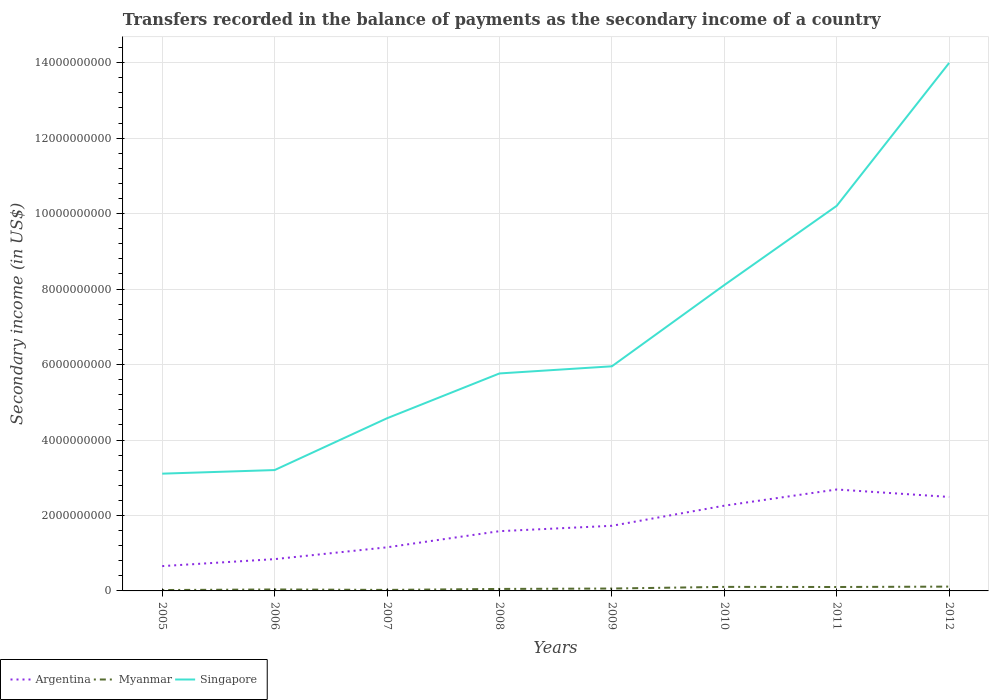Does the line corresponding to Argentina intersect with the line corresponding to Singapore?
Provide a short and direct response. No. Across all years, what is the maximum secondary income of in Singapore?
Provide a short and direct response. 3.11e+09. What is the total secondary income of in Myanmar in the graph?
Give a very brief answer. -2.54e+07. What is the difference between the highest and the second highest secondary income of in Argentina?
Provide a succinct answer. 2.03e+09. Is the secondary income of in Singapore strictly greater than the secondary income of in Argentina over the years?
Keep it short and to the point. No. How many years are there in the graph?
Offer a terse response. 8. What is the difference between two consecutive major ticks on the Y-axis?
Ensure brevity in your answer.  2.00e+09. Does the graph contain grids?
Keep it short and to the point. Yes. Where does the legend appear in the graph?
Ensure brevity in your answer.  Bottom left. How many legend labels are there?
Offer a very short reply. 3. What is the title of the graph?
Offer a very short reply. Transfers recorded in the balance of payments as the secondary income of a country. Does "Canada" appear as one of the legend labels in the graph?
Your answer should be compact. No. What is the label or title of the Y-axis?
Ensure brevity in your answer.  Secondary income (in US$). What is the Secondary income (in US$) in Argentina in 2005?
Ensure brevity in your answer.  6.58e+08. What is the Secondary income (in US$) of Myanmar in 2005?
Offer a very short reply. 2.36e+07. What is the Secondary income (in US$) of Singapore in 2005?
Your answer should be very brief. 3.11e+09. What is the Secondary income (in US$) in Argentina in 2006?
Provide a short and direct response. 8.43e+08. What is the Secondary income (in US$) in Myanmar in 2006?
Keep it short and to the point. 3.87e+07. What is the Secondary income (in US$) in Singapore in 2006?
Your response must be concise. 3.20e+09. What is the Secondary income (in US$) in Argentina in 2007?
Provide a succinct answer. 1.16e+09. What is the Secondary income (in US$) of Myanmar in 2007?
Keep it short and to the point. 2.72e+07. What is the Secondary income (in US$) in Singapore in 2007?
Offer a terse response. 4.58e+09. What is the Secondary income (in US$) in Argentina in 2008?
Provide a short and direct response. 1.58e+09. What is the Secondary income (in US$) of Myanmar in 2008?
Give a very brief answer. 5.26e+07. What is the Secondary income (in US$) of Singapore in 2008?
Your response must be concise. 5.76e+09. What is the Secondary income (in US$) in Argentina in 2009?
Offer a very short reply. 1.73e+09. What is the Secondary income (in US$) of Myanmar in 2009?
Provide a succinct answer. 6.34e+07. What is the Secondary income (in US$) in Singapore in 2009?
Keep it short and to the point. 5.95e+09. What is the Secondary income (in US$) of Argentina in 2010?
Your response must be concise. 2.26e+09. What is the Secondary income (in US$) in Myanmar in 2010?
Provide a short and direct response. 1.07e+08. What is the Secondary income (in US$) of Singapore in 2010?
Offer a very short reply. 8.11e+09. What is the Secondary income (in US$) in Argentina in 2011?
Keep it short and to the point. 2.69e+09. What is the Secondary income (in US$) of Myanmar in 2011?
Keep it short and to the point. 1.04e+08. What is the Secondary income (in US$) in Singapore in 2011?
Your response must be concise. 1.02e+1. What is the Secondary income (in US$) of Argentina in 2012?
Keep it short and to the point. 2.49e+09. What is the Secondary income (in US$) of Myanmar in 2012?
Offer a very short reply. 1.14e+08. What is the Secondary income (in US$) in Singapore in 2012?
Offer a terse response. 1.40e+1. Across all years, what is the maximum Secondary income (in US$) in Argentina?
Your response must be concise. 2.69e+09. Across all years, what is the maximum Secondary income (in US$) in Myanmar?
Provide a succinct answer. 1.14e+08. Across all years, what is the maximum Secondary income (in US$) in Singapore?
Make the answer very short. 1.40e+1. Across all years, what is the minimum Secondary income (in US$) in Argentina?
Your answer should be compact. 6.58e+08. Across all years, what is the minimum Secondary income (in US$) in Myanmar?
Your response must be concise. 2.36e+07. Across all years, what is the minimum Secondary income (in US$) of Singapore?
Your answer should be very brief. 3.11e+09. What is the total Secondary income (in US$) of Argentina in the graph?
Your answer should be very brief. 1.34e+1. What is the total Secondary income (in US$) in Myanmar in the graph?
Your answer should be very brief. 5.31e+08. What is the total Secondary income (in US$) of Singapore in the graph?
Keep it short and to the point. 5.49e+1. What is the difference between the Secondary income (in US$) of Argentina in 2005 and that in 2006?
Ensure brevity in your answer.  -1.85e+08. What is the difference between the Secondary income (in US$) in Myanmar in 2005 and that in 2006?
Your answer should be very brief. -1.51e+07. What is the difference between the Secondary income (in US$) in Singapore in 2005 and that in 2006?
Keep it short and to the point. -9.54e+07. What is the difference between the Secondary income (in US$) of Argentina in 2005 and that in 2007?
Offer a terse response. -4.98e+08. What is the difference between the Secondary income (in US$) in Myanmar in 2005 and that in 2007?
Offer a terse response. -3.60e+06. What is the difference between the Secondary income (in US$) in Singapore in 2005 and that in 2007?
Offer a very short reply. -1.47e+09. What is the difference between the Secondary income (in US$) in Argentina in 2005 and that in 2008?
Your response must be concise. -9.26e+08. What is the difference between the Secondary income (in US$) in Myanmar in 2005 and that in 2008?
Provide a short and direct response. -2.90e+07. What is the difference between the Secondary income (in US$) of Singapore in 2005 and that in 2008?
Give a very brief answer. -2.66e+09. What is the difference between the Secondary income (in US$) in Argentina in 2005 and that in 2009?
Ensure brevity in your answer.  -1.07e+09. What is the difference between the Secondary income (in US$) of Myanmar in 2005 and that in 2009?
Your response must be concise. -3.98e+07. What is the difference between the Secondary income (in US$) of Singapore in 2005 and that in 2009?
Offer a very short reply. -2.85e+09. What is the difference between the Secondary income (in US$) in Argentina in 2005 and that in 2010?
Your answer should be compact. -1.60e+09. What is the difference between the Secondary income (in US$) in Myanmar in 2005 and that in 2010?
Give a very brief answer. -8.35e+07. What is the difference between the Secondary income (in US$) of Singapore in 2005 and that in 2010?
Your answer should be compact. -5.00e+09. What is the difference between the Secondary income (in US$) of Argentina in 2005 and that in 2011?
Offer a very short reply. -2.03e+09. What is the difference between the Secondary income (in US$) of Myanmar in 2005 and that in 2011?
Provide a succinct answer. -8.04e+07. What is the difference between the Secondary income (in US$) in Singapore in 2005 and that in 2011?
Provide a short and direct response. -7.10e+09. What is the difference between the Secondary income (in US$) of Argentina in 2005 and that in 2012?
Your response must be concise. -1.83e+09. What is the difference between the Secondary income (in US$) in Myanmar in 2005 and that in 2012?
Your answer should be compact. -9.07e+07. What is the difference between the Secondary income (in US$) of Singapore in 2005 and that in 2012?
Your response must be concise. -1.09e+1. What is the difference between the Secondary income (in US$) of Argentina in 2006 and that in 2007?
Provide a succinct answer. -3.13e+08. What is the difference between the Secondary income (in US$) in Myanmar in 2006 and that in 2007?
Your answer should be very brief. 1.15e+07. What is the difference between the Secondary income (in US$) in Singapore in 2006 and that in 2007?
Provide a succinct answer. -1.37e+09. What is the difference between the Secondary income (in US$) in Argentina in 2006 and that in 2008?
Provide a short and direct response. -7.41e+08. What is the difference between the Secondary income (in US$) of Myanmar in 2006 and that in 2008?
Give a very brief answer. -1.40e+07. What is the difference between the Secondary income (in US$) in Singapore in 2006 and that in 2008?
Make the answer very short. -2.56e+09. What is the difference between the Secondary income (in US$) of Argentina in 2006 and that in 2009?
Your answer should be very brief. -8.84e+08. What is the difference between the Secondary income (in US$) of Myanmar in 2006 and that in 2009?
Make the answer very short. -2.48e+07. What is the difference between the Secondary income (in US$) in Singapore in 2006 and that in 2009?
Offer a terse response. -2.75e+09. What is the difference between the Secondary income (in US$) of Argentina in 2006 and that in 2010?
Your answer should be compact. -1.42e+09. What is the difference between the Secondary income (in US$) in Myanmar in 2006 and that in 2010?
Offer a terse response. -6.84e+07. What is the difference between the Secondary income (in US$) in Singapore in 2006 and that in 2010?
Your response must be concise. -4.90e+09. What is the difference between the Secondary income (in US$) in Argentina in 2006 and that in 2011?
Provide a short and direct response. -1.85e+09. What is the difference between the Secondary income (in US$) of Myanmar in 2006 and that in 2011?
Give a very brief answer. -6.53e+07. What is the difference between the Secondary income (in US$) in Singapore in 2006 and that in 2011?
Provide a short and direct response. -7.00e+09. What is the difference between the Secondary income (in US$) of Argentina in 2006 and that in 2012?
Offer a very short reply. -1.65e+09. What is the difference between the Secondary income (in US$) in Myanmar in 2006 and that in 2012?
Your answer should be very brief. -7.56e+07. What is the difference between the Secondary income (in US$) in Singapore in 2006 and that in 2012?
Offer a very short reply. -1.08e+1. What is the difference between the Secondary income (in US$) in Argentina in 2007 and that in 2008?
Your answer should be compact. -4.28e+08. What is the difference between the Secondary income (in US$) in Myanmar in 2007 and that in 2008?
Your answer should be very brief. -2.54e+07. What is the difference between the Secondary income (in US$) of Singapore in 2007 and that in 2008?
Your answer should be very brief. -1.19e+09. What is the difference between the Secondary income (in US$) of Argentina in 2007 and that in 2009?
Ensure brevity in your answer.  -5.70e+08. What is the difference between the Secondary income (in US$) in Myanmar in 2007 and that in 2009?
Give a very brief answer. -3.62e+07. What is the difference between the Secondary income (in US$) in Singapore in 2007 and that in 2009?
Your answer should be very brief. -1.38e+09. What is the difference between the Secondary income (in US$) in Argentina in 2007 and that in 2010?
Provide a succinct answer. -1.10e+09. What is the difference between the Secondary income (in US$) in Myanmar in 2007 and that in 2010?
Offer a very short reply. -7.99e+07. What is the difference between the Secondary income (in US$) in Singapore in 2007 and that in 2010?
Keep it short and to the point. -3.53e+09. What is the difference between the Secondary income (in US$) of Argentina in 2007 and that in 2011?
Ensure brevity in your answer.  -1.53e+09. What is the difference between the Secondary income (in US$) in Myanmar in 2007 and that in 2011?
Give a very brief answer. -7.68e+07. What is the difference between the Secondary income (in US$) of Singapore in 2007 and that in 2011?
Give a very brief answer. -5.63e+09. What is the difference between the Secondary income (in US$) in Argentina in 2007 and that in 2012?
Provide a succinct answer. -1.34e+09. What is the difference between the Secondary income (in US$) in Myanmar in 2007 and that in 2012?
Offer a terse response. -8.71e+07. What is the difference between the Secondary income (in US$) of Singapore in 2007 and that in 2012?
Your answer should be very brief. -9.42e+09. What is the difference between the Secondary income (in US$) of Argentina in 2008 and that in 2009?
Offer a terse response. -1.43e+08. What is the difference between the Secondary income (in US$) in Myanmar in 2008 and that in 2009?
Your answer should be compact. -1.08e+07. What is the difference between the Secondary income (in US$) in Singapore in 2008 and that in 2009?
Your response must be concise. -1.89e+08. What is the difference between the Secondary income (in US$) of Argentina in 2008 and that in 2010?
Provide a short and direct response. -6.76e+08. What is the difference between the Secondary income (in US$) of Myanmar in 2008 and that in 2010?
Your response must be concise. -5.45e+07. What is the difference between the Secondary income (in US$) in Singapore in 2008 and that in 2010?
Your answer should be compact. -2.34e+09. What is the difference between the Secondary income (in US$) in Argentina in 2008 and that in 2011?
Your response must be concise. -1.10e+09. What is the difference between the Secondary income (in US$) in Myanmar in 2008 and that in 2011?
Make the answer very short. -5.13e+07. What is the difference between the Secondary income (in US$) in Singapore in 2008 and that in 2011?
Your answer should be very brief. -4.44e+09. What is the difference between the Secondary income (in US$) of Argentina in 2008 and that in 2012?
Make the answer very short. -9.07e+08. What is the difference between the Secondary income (in US$) of Myanmar in 2008 and that in 2012?
Your answer should be compact. -6.17e+07. What is the difference between the Secondary income (in US$) in Singapore in 2008 and that in 2012?
Your answer should be compact. -8.23e+09. What is the difference between the Secondary income (in US$) in Argentina in 2009 and that in 2010?
Your answer should be very brief. -5.33e+08. What is the difference between the Secondary income (in US$) of Myanmar in 2009 and that in 2010?
Your answer should be compact. -4.37e+07. What is the difference between the Secondary income (in US$) in Singapore in 2009 and that in 2010?
Provide a succinct answer. -2.15e+09. What is the difference between the Secondary income (in US$) in Argentina in 2009 and that in 2011?
Your answer should be compact. -9.62e+08. What is the difference between the Secondary income (in US$) of Myanmar in 2009 and that in 2011?
Give a very brief answer. -4.05e+07. What is the difference between the Secondary income (in US$) of Singapore in 2009 and that in 2011?
Your answer should be compact. -4.25e+09. What is the difference between the Secondary income (in US$) in Argentina in 2009 and that in 2012?
Give a very brief answer. -7.65e+08. What is the difference between the Secondary income (in US$) in Myanmar in 2009 and that in 2012?
Your answer should be very brief. -5.09e+07. What is the difference between the Secondary income (in US$) in Singapore in 2009 and that in 2012?
Your response must be concise. -8.04e+09. What is the difference between the Secondary income (in US$) of Argentina in 2010 and that in 2011?
Your answer should be very brief. -4.29e+08. What is the difference between the Secondary income (in US$) of Myanmar in 2010 and that in 2011?
Give a very brief answer. 3.15e+06. What is the difference between the Secondary income (in US$) of Singapore in 2010 and that in 2011?
Provide a short and direct response. -2.10e+09. What is the difference between the Secondary income (in US$) in Argentina in 2010 and that in 2012?
Your response must be concise. -2.31e+08. What is the difference between the Secondary income (in US$) in Myanmar in 2010 and that in 2012?
Your answer should be very brief. -7.21e+06. What is the difference between the Secondary income (in US$) in Singapore in 2010 and that in 2012?
Offer a terse response. -5.89e+09. What is the difference between the Secondary income (in US$) of Argentina in 2011 and that in 2012?
Keep it short and to the point. 1.97e+08. What is the difference between the Secondary income (in US$) of Myanmar in 2011 and that in 2012?
Offer a very short reply. -1.04e+07. What is the difference between the Secondary income (in US$) of Singapore in 2011 and that in 2012?
Give a very brief answer. -3.79e+09. What is the difference between the Secondary income (in US$) of Argentina in 2005 and the Secondary income (in US$) of Myanmar in 2006?
Ensure brevity in your answer.  6.19e+08. What is the difference between the Secondary income (in US$) in Argentina in 2005 and the Secondary income (in US$) in Singapore in 2006?
Give a very brief answer. -2.55e+09. What is the difference between the Secondary income (in US$) in Myanmar in 2005 and the Secondary income (in US$) in Singapore in 2006?
Give a very brief answer. -3.18e+09. What is the difference between the Secondary income (in US$) of Argentina in 2005 and the Secondary income (in US$) of Myanmar in 2007?
Your response must be concise. 6.31e+08. What is the difference between the Secondary income (in US$) in Argentina in 2005 and the Secondary income (in US$) in Singapore in 2007?
Offer a terse response. -3.92e+09. What is the difference between the Secondary income (in US$) in Myanmar in 2005 and the Secondary income (in US$) in Singapore in 2007?
Keep it short and to the point. -4.55e+09. What is the difference between the Secondary income (in US$) of Argentina in 2005 and the Secondary income (in US$) of Myanmar in 2008?
Keep it short and to the point. 6.05e+08. What is the difference between the Secondary income (in US$) of Argentina in 2005 and the Secondary income (in US$) of Singapore in 2008?
Your response must be concise. -5.11e+09. What is the difference between the Secondary income (in US$) in Myanmar in 2005 and the Secondary income (in US$) in Singapore in 2008?
Make the answer very short. -5.74e+09. What is the difference between the Secondary income (in US$) of Argentina in 2005 and the Secondary income (in US$) of Myanmar in 2009?
Ensure brevity in your answer.  5.94e+08. What is the difference between the Secondary income (in US$) of Argentina in 2005 and the Secondary income (in US$) of Singapore in 2009?
Ensure brevity in your answer.  -5.30e+09. What is the difference between the Secondary income (in US$) of Myanmar in 2005 and the Secondary income (in US$) of Singapore in 2009?
Your response must be concise. -5.93e+09. What is the difference between the Secondary income (in US$) of Argentina in 2005 and the Secondary income (in US$) of Myanmar in 2010?
Keep it short and to the point. 5.51e+08. What is the difference between the Secondary income (in US$) of Argentina in 2005 and the Secondary income (in US$) of Singapore in 2010?
Provide a short and direct response. -7.45e+09. What is the difference between the Secondary income (in US$) in Myanmar in 2005 and the Secondary income (in US$) in Singapore in 2010?
Provide a short and direct response. -8.08e+09. What is the difference between the Secondary income (in US$) in Argentina in 2005 and the Secondary income (in US$) in Myanmar in 2011?
Provide a succinct answer. 5.54e+08. What is the difference between the Secondary income (in US$) in Argentina in 2005 and the Secondary income (in US$) in Singapore in 2011?
Give a very brief answer. -9.55e+09. What is the difference between the Secondary income (in US$) of Myanmar in 2005 and the Secondary income (in US$) of Singapore in 2011?
Offer a very short reply. -1.02e+1. What is the difference between the Secondary income (in US$) in Argentina in 2005 and the Secondary income (in US$) in Myanmar in 2012?
Offer a terse response. 5.44e+08. What is the difference between the Secondary income (in US$) of Argentina in 2005 and the Secondary income (in US$) of Singapore in 2012?
Your answer should be compact. -1.33e+1. What is the difference between the Secondary income (in US$) of Myanmar in 2005 and the Secondary income (in US$) of Singapore in 2012?
Give a very brief answer. -1.40e+1. What is the difference between the Secondary income (in US$) of Argentina in 2006 and the Secondary income (in US$) of Myanmar in 2007?
Your answer should be compact. 8.15e+08. What is the difference between the Secondary income (in US$) in Argentina in 2006 and the Secondary income (in US$) in Singapore in 2007?
Give a very brief answer. -3.73e+09. What is the difference between the Secondary income (in US$) of Myanmar in 2006 and the Secondary income (in US$) of Singapore in 2007?
Your answer should be compact. -4.54e+09. What is the difference between the Secondary income (in US$) in Argentina in 2006 and the Secondary income (in US$) in Myanmar in 2008?
Your response must be concise. 7.90e+08. What is the difference between the Secondary income (in US$) in Argentina in 2006 and the Secondary income (in US$) in Singapore in 2008?
Give a very brief answer. -4.92e+09. What is the difference between the Secondary income (in US$) in Myanmar in 2006 and the Secondary income (in US$) in Singapore in 2008?
Ensure brevity in your answer.  -5.73e+09. What is the difference between the Secondary income (in US$) of Argentina in 2006 and the Secondary income (in US$) of Myanmar in 2009?
Provide a succinct answer. 7.79e+08. What is the difference between the Secondary income (in US$) of Argentina in 2006 and the Secondary income (in US$) of Singapore in 2009?
Ensure brevity in your answer.  -5.11e+09. What is the difference between the Secondary income (in US$) of Myanmar in 2006 and the Secondary income (in US$) of Singapore in 2009?
Your answer should be very brief. -5.91e+09. What is the difference between the Secondary income (in US$) of Argentina in 2006 and the Secondary income (in US$) of Myanmar in 2010?
Give a very brief answer. 7.36e+08. What is the difference between the Secondary income (in US$) of Argentina in 2006 and the Secondary income (in US$) of Singapore in 2010?
Keep it short and to the point. -7.26e+09. What is the difference between the Secondary income (in US$) in Myanmar in 2006 and the Secondary income (in US$) in Singapore in 2010?
Your answer should be compact. -8.07e+09. What is the difference between the Secondary income (in US$) of Argentina in 2006 and the Secondary income (in US$) of Myanmar in 2011?
Give a very brief answer. 7.39e+08. What is the difference between the Secondary income (in US$) of Argentina in 2006 and the Secondary income (in US$) of Singapore in 2011?
Ensure brevity in your answer.  -9.36e+09. What is the difference between the Secondary income (in US$) of Myanmar in 2006 and the Secondary income (in US$) of Singapore in 2011?
Provide a short and direct response. -1.02e+1. What is the difference between the Secondary income (in US$) of Argentina in 2006 and the Secondary income (in US$) of Myanmar in 2012?
Offer a very short reply. 7.28e+08. What is the difference between the Secondary income (in US$) in Argentina in 2006 and the Secondary income (in US$) in Singapore in 2012?
Keep it short and to the point. -1.32e+1. What is the difference between the Secondary income (in US$) of Myanmar in 2006 and the Secondary income (in US$) of Singapore in 2012?
Keep it short and to the point. -1.40e+1. What is the difference between the Secondary income (in US$) of Argentina in 2007 and the Secondary income (in US$) of Myanmar in 2008?
Your answer should be compact. 1.10e+09. What is the difference between the Secondary income (in US$) of Argentina in 2007 and the Secondary income (in US$) of Singapore in 2008?
Offer a terse response. -4.61e+09. What is the difference between the Secondary income (in US$) in Myanmar in 2007 and the Secondary income (in US$) in Singapore in 2008?
Ensure brevity in your answer.  -5.74e+09. What is the difference between the Secondary income (in US$) in Argentina in 2007 and the Secondary income (in US$) in Myanmar in 2009?
Your response must be concise. 1.09e+09. What is the difference between the Secondary income (in US$) of Argentina in 2007 and the Secondary income (in US$) of Singapore in 2009?
Ensure brevity in your answer.  -4.80e+09. What is the difference between the Secondary income (in US$) in Myanmar in 2007 and the Secondary income (in US$) in Singapore in 2009?
Your answer should be compact. -5.93e+09. What is the difference between the Secondary income (in US$) of Argentina in 2007 and the Secondary income (in US$) of Myanmar in 2010?
Provide a short and direct response. 1.05e+09. What is the difference between the Secondary income (in US$) of Argentina in 2007 and the Secondary income (in US$) of Singapore in 2010?
Ensure brevity in your answer.  -6.95e+09. What is the difference between the Secondary income (in US$) in Myanmar in 2007 and the Secondary income (in US$) in Singapore in 2010?
Make the answer very short. -8.08e+09. What is the difference between the Secondary income (in US$) in Argentina in 2007 and the Secondary income (in US$) in Myanmar in 2011?
Your answer should be compact. 1.05e+09. What is the difference between the Secondary income (in US$) in Argentina in 2007 and the Secondary income (in US$) in Singapore in 2011?
Provide a succinct answer. -9.05e+09. What is the difference between the Secondary income (in US$) in Myanmar in 2007 and the Secondary income (in US$) in Singapore in 2011?
Your answer should be compact. -1.02e+1. What is the difference between the Secondary income (in US$) of Argentina in 2007 and the Secondary income (in US$) of Myanmar in 2012?
Ensure brevity in your answer.  1.04e+09. What is the difference between the Secondary income (in US$) in Argentina in 2007 and the Secondary income (in US$) in Singapore in 2012?
Make the answer very short. -1.28e+1. What is the difference between the Secondary income (in US$) in Myanmar in 2007 and the Secondary income (in US$) in Singapore in 2012?
Keep it short and to the point. -1.40e+1. What is the difference between the Secondary income (in US$) of Argentina in 2008 and the Secondary income (in US$) of Myanmar in 2009?
Your answer should be very brief. 1.52e+09. What is the difference between the Secondary income (in US$) in Argentina in 2008 and the Secondary income (in US$) in Singapore in 2009?
Your answer should be compact. -4.37e+09. What is the difference between the Secondary income (in US$) of Myanmar in 2008 and the Secondary income (in US$) of Singapore in 2009?
Your answer should be compact. -5.90e+09. What is the difference between the Secondary income (in US$) of Argentina in 2008 and the Secondary income (in US$) of Myanmar in 2010?
Your answer should be very brief. 1.48e+09. What is the difference between the Secondary income (in US$) in Argentina in 2008 and the Secondary income (in US$) in Singapore in 2010?
Provide a succinct answer. -6.52e+09. What is the difference between the Secondary income (in US$) of Myanmar in 2008 and the Secondary income (in US$) of Singapore in 2010?
Give a very brief answer. -8.05e+09. What is the difference between the Secondary income (in US$) in Argentina in 2008 and the Secondary income (in US$) in Myanmar in 2011?
Keep it short and to the point. 1.48e+09. What is the difference between the Secondary income (in US$) in Argentina in 2008 and the Secondary income (in US$) in Singapore in 2011?
Your answer should be very brief. -8.62e+09. What is the difference between the Secondary income (in US$) in Myanmar in 2008 and the Secondary income (in US$) in Singapore in 2011?
Provide a succinct answer. -1.02e+1. What is the difference between the Secondary income (in US$) in Argentina in 2008 and the Secondary income (in US$) in Myanmar in 2012?
Make the answer very short. 1.47e+09. What is the difference between the Secondary income (in US$) in Argentina in 2008 and the Secondary income (in US$) in Singapore in 2012?
Your response must be concise. -1.24e+1. What is the difference between the Secondary income (in US$) of Myanmar in 2008 and the Secondary income (in US$) of Singapore in 2012?
Make the answer very short. -1.39e+1. What is the difference between the Secondary income (in US$) of Argentina in 2009 and the Secondary income (in US$) of Myanmar in 2010?
Give a very brief answer. 1.62e+09. What is the difference between the Secondary income (in US$) in Argentina in 2009 and the Secondary income (in US$) in Singapore in 2010?
Offer a terse response. -6.38e+09. What is the difference between the Secondary income (in US$) in Myanmar in 2009 and the Secondary income (in US$) in Singapore in 2010?
Provide a short and direct response. -8.04e+09. What is the difference between the Secondary income (in US$) of Argentina in 2009 and the Secondary income (in US$) of Myanmar in 2011?
Your answer should be very brief. 1.62e+09. What is the difference between the Secondary income (in US$) of Argentina in 2009 and the Secondary income (in US$) of Singapore in 2011?
Offer a terse response. -8.48e+09. What is the difference between the Secondary income (in US$) in Myanmar in 2009 and the Secondary income (in US$) in Singapore in 2011?
Make the answer very short. -1.01e+1. What is the difference between the Secondary income (in US$) in Argentina in 2009 and the Secondary income (in US$) in Myanmar in 2012?
Provide a succinct answer. 1.61e+09. What is the difference between the Secondary income (in US$) in Argentina in 2009 and the Secondary income (in US$) in Singapore in 2012?
Provide a short and direct response. -1.23e+1. What is the difference between the Secondary income (in US$) in Myanmar in 2009 and the Secondary income (in US$) in Singapore in 2012?
Provide a short and direct response. -1.39e+1. What is the difference between the Secondary income (in US$) of Argentina in 2010 and the Secondary income (in US$) of Myanmar in 2011?
Keep it short and to the point. 2.16e+09. What is the difference between the Secondary income (in US$) of Argentina in 2010 and the Secondary income (in US$) of Singapore in 2011?
Keep it short and to the point. -7.95e+09. What is the difference between the Secondary income (in US$) of Myanmar in 2010 and the Secondary income (in US$) of Singapore in 2011?
Offer a terse response. -1.01e+1. What is the difference between the Secondary income (in US$) of Argentina in 2010 and the Secondary income (in US$) of Myanmar in 2012?
Offer a very short reply. 2.15e+09. What is the difference between the Secondary income (in US$) in Argentina in 2010 and the Secondary income (in US$) in Singapore in 2012?
Make the answer very short. -1.17e+1. What is the difference between the Secondary income (in US$) of Myanmar in 2010 and the Secondary income (in US$) of Singapore in 2012?
Offer a very short reply. -1.39e+1. What is the difference between the Secondary income (in US$) in Argentina in 2011 and the Secondary income (in US$) in Myanmar in 2012?
Offer a very short reply. 2.57e+09. What is the difference between the Secondary income (in US$) of Argentina in 2011 and the Secondary income (in US$) of Singapore in 2012?
Give a very brief answer. -1.13e+1. What is the difference between the Secondary income (in US$) of Myanmar in 2011 and the Secondary income (in US$) of Singapore in 2012?
Offer a very short reply. -1.39e+1. What is the average Secondary income (in US$) of Argentina per year?
Ensure brevity in your answer.  1.68e+09. What is the average Secondary income (in US$) of Myanmar per year?
Provide a short and direct response. 6.63e+07. What is the average Secondary income (in US$) of Singapore per year?
Give a very brief answer. 6.86e+09. In the year 2005, what is the difference between the Secondary income (in US$) in Argentina and Secondary income (in US$) in Myanmar?
Ensure brevity in your answer.  6.34e+08. In the year 2005, what is the difference between the Secondary income (in US$) in Argentina and Secondary income (in US$) in Singapore?
Offer a terse response. -2.45e+09. In the year 2005, what is the difference between the Secondary income (in US$) of Myanmar and Secondary income (in US$) of Singapore?
Your response must be concise. -3.08e+09. In the year 2006, what is the difference between the Secondary income (in US$) in Argentina and Secondary income (in US$) in Myanmar?
Offer a terse response. 8.04e+08. In the year 2006, what is the difference between the Secondary income (in US$) of Argentina and Secondary income (in US$) of Singapore?
Provide a short and direct response. -2.36e+09. In the year 2006, what is the difference between the Secondary income (in US$) in Myanmar and Secondary income (in US$) in Singapore?
Your answer should be very brief. -3.16e+09. In the year 2007, what is the difference between the Secondary income (in US$) in Argentina and Secondary income (in US$) in Myanmar?
Your response must be concise. 1.13e+09. In the year 2007, what is the difference between the Secondary income (in US$) of Argentina and Secondary income (in US$) of Singapore?
Ensure brevity in your answer.  -3.42e+09. In the year 2007, what is the difference between the Secondary income (in US$) in Myanmar and Secondary income (in US$) in Singapore?
Your response must be concise. -4.55e+09. In the year 2008, what is the difference between the Secondary income (in US$) of Argentina and Secondary income (in US$) of Myanmar?
Give a very brief answer. 1.53e+09. In the year 2008, what is the difference between the Secondary income (in US$) in Argentina and Secondary income (in US$) in Singapore?
Provide a short and direct response. -4.18e+09. In the year 2008, what is the difference between the Secondary income (in US$) in Myanmar and Secondary income (in US$) in Singapore?
Provide a succinct answer. -5.71e+09. In the year 2009, what is the difference between the Secondary income (in US$) of Argentina and Secondary income (in US$) of Myanmar?
Keep it short and to the point. 1.66e+09. In the year 2009, what is the difference between the Secondary income (in US$) in Argentina and Secondary income (in US$) in Singapore?
Offer a very short reply. -4.23e+09. In the year 2009, what is the difference between the Secondary income (in US$) in Myanmar and Secondary income (in US$) in Singapore?
Provide a short and direct response. -5.89e+09. In the year 2010, what is the difference between the Secondary income (in US$) of Argentina and Secondary income (in US$) of Myanmar?
Provide a short and direct response. 2.15e+09. In the year 2010, what is the difference between the Secondary income (in US$) of Argentina and Secondary income (in US$) of Singapore?
Your answer should be very brief. -5.85e+09. In the year 2010, what is the difference between the Secondary income (in US$) of Myanmar and Secondary income (in US$) of Singapore?
Provide a succinct answer. -8.00e+09. In the year 2011, what is the difference between the Secondary income (in US$) in Argentina and Secondary income (in US$) in Myanmar?
Your answer should be compact. 2.58e+09. In the year 2011, what is the difference between the Secondary income (in US$) in Argentina and Secondary income (in US$) in Singapore?
Keep it short and to the point. -7.52e+09. In the year 2011, what is the difference between the Secondary income (in US$) in Myanmar and Secondary income (in US$) in Singapore?
Offer a very short reply. -1.01e+1. In the year 2012, what is the difference between the Secondary income (in US$) of Argentina and Secondary income (in US$) of Myanmar?
Provide a short and direct response. 2.38e+09. In the year 2012, what is the difference between the Secondary income (in US$) in Argentina and Secondary income (in US$) in Singapore?
Keep it short and to the point. -1.15e+1. In the year 2012, what is the difference between the Secondary income (in US$) of Myanmar and Secondary income (in US$) of Singapore?
Give a very brief answer. -1.39e+1. What is the ratio of the Secondary income (in US$) of Argentina in 2005 to that in 2006?
Offer a very short reply. 0.78. What is the ratio of the Secondary income (in US$) of Myanmar in 2005 to that in 2006?
Your answer should be very brief. 0.61. What is the ratio of the Secondary income (in US$) in Singapore in 2005 to that in 2006?
Your answer should be compact. 0.97. What is the ratio of the Secondary income (in US$) in Argentina in 2005 to that in 2007?
Provide a short and direct response. 0.57. What is the ratio of the Secondary income (in US$) of Myanmar in 2005 to that in 2007?
Provide a short and direct response. 0.87. What is the ratio of the Secondary income (in US$) in Singapore in 2005 to that in 2007?
Make the answer very short. 0.68. What is the ratio of the Secondary income (in US$) of Argentina in 2005 to that in 2008?
Offer a very short reply. 0.42. What is the ratio of the Secondary income (in US$) in Myanmar in 2005 to that in 2008?
Ensure brevity in your answer.  0.45. What is the ratio of the Secondary income (in US$) in Singapore in 2005 to that in 2008?
Offer a terse response. 0.54. What is the ratio of the Secondary income (in US$) of Argentina in 2005 to that in 2009?
Provide a short and direct response. 0.38. What is the ratio of the Secondary income (in US$) of Myanmar in 2005 to that in 2009?
Keep it short and to the point. 0.37. What is the ratio of the Secondary income (in US$) in Singapore in 2005 to that in 2009?
Give a very brief answer. 0.52. What is the ratio of the Secondary income (in US$) of Argentina in 2005 to that in 2010?
Keep it short and to the point. 0.29. What is the ratio of the Secondary income (in US$) in Myanmar in 2005 to that in 2010?
Make the answer very short. 0.22. What is the ratio of the Secondary income (in US$) of Singapore in 2005 to that in 2010?
Your answer should be very brief. 0.38. What is the ratio of the Secondary income (in US$) of Argentina in 2005 to that in 2011?
Offer a terse response. 0.24. What is the ratio of the Secondary income (in US$) in Myanmar in 2005 to that in 2011?
Make the answer very short. 0.23. What is the ratio of the Secondary income (in US$) in Singapore in 2005 to that in 2011?
Your response must be concise. 0.3. What is the ratio of the Secondary income (in US$) in Argentina in 2005 to that in 2012?
Your answer should be compact. 0.26. What is the ratio of the Secondary income (in US$) in Myanmar in 2005 to that in 2012?
Offer a terse response. 0.21. What is the ratio of the Secondary income (in US$) in Singapore in 2005 to that in 2012?
Keep it short and to the point. 0.22. What is the ratio of the Secondary income (in US$) in Argentina in 2006 to that in 2007?
Offer a very short reply. 0.73. What is the ratio of the Secondary income (in US$) of Myanmar in 2006 to that in 2007?
Provide a short and direct response. 1.42. What is the ratio of the Secondary income (in US$) in Singapore in 2006 to that in 2007?
Your response must be concise. 0.7. What is the ratio of the Secondary income (in US$) of Argentina in 2006 to that in 2008?
Your response must be concise. 0.53. What is the ratio of the Secondary income (in US$) of Myanmar in 2006 to that in 2008?
Make the answer very short. 0.73. What is the ratio of the Secondary income (in US$) in Singapore in 2006 to that in 2008?
Your response must be concise. 0.56. What is the ratio of the Secondary income (in US$) in Argentina in 2006 to that in 2009?
Your response must be concise. 0.49. What is the ratio of the Secondary income (in US$) of Myanmar in 2006 to that in 2009?
Keep it short and to the point. 0.61. What is the ratio of the Secondary income (in US$) in Singapore in 2006 to that in 2009?
Give a very brief answer. 0.54. What is the ratio of the Secondary income (in US$) in Argentina in 2006 to that in 2010?
Your response must be concise. 0.37. What is the ratio of the Secondary income (in US$) of Myanmar in 2006 to that in 2010?
Your answer should be compact. 0.36. What is the ratio of the Secondary income (in US$) in Singapore in 2006 to that in 2010?
Keep it short and to the point. 0.4. What is the ratio of the Secondary income (in US$) of Argentina in 2006 to that in 2011?
Your answer should be compact. 0.31. What is the ratio of the Secondary income (in US$) of Myanmar in 2006 to that in 2011?
Offer a terse response. 0.37. What is the ratio of the Secondary income (in US$) of Singapore in 2006 to that in 2011?
Your answer should be compact. 0.31. What is the ratio of the Secondary income (in US$) in Argentina in 2006 to that in 2012?
Make the answer very short. 0.34. What is the ratio of the Secondary income (in US$) of Myanmar in 2006 to that in 2012?
Your response must be concise. 0.34. What is the ratio of the Secondary income (in US$) of Singapore in 2006 to that in 2012?
Your response must be concise. 0.23. What is the ratio of the Secondary income (in US$) in Argentina in 2007 to that in 2008?
Offer a terse response. 0.73. What is the ratio of the Secondary income (in US$) in Myanmar in 2007 to that in 2008?
Provide a succinct answer. 0.52. What is the ratio of the Secondary income (in US$) of Singapore in 2007 to that in 2008?
Keep it short and to the point. 0.79. What is the ratio of the Secondary income (in US$) in Argentina in 2007 to that in 2009?
Your response must be concise. 0.67. What is the ratio of the Secondary income (in US$) of Myanmar in 2007 to that in 2009?
Your answer should be very brief. 0.43. What is the ratio of the Secondary income (in US$) of Singapore in 2007 to that in 2009?
Provide a short and direct response. 0.77. What is the ratio of the Secondary income (in US$) in Argentina in 2007 to that in 2010?
Provide a short and direct response. 0.51. What is the ratio of the Secondary income (in US$) of Myanmar in 2007 to that in 2010?
Provide a short and direct response. 0.25. What is the ratio of the Secondary income (in US$) of Singapore in 2007 to that in 2010?
Give a very brief answer. 0.56. What is the ratio of the Secondary income (in US$) of Argentina in 2007 to that in 2011?
Your answer should be very brief. 0.43. What is the ratio of the Secondary income (in US$) of Myanmar in 2007 to that in 2011?
Your response must be concise. 0.26. What is the ratio of the Secondary income (in US$) in Singapore in 2007 to that in 2011?
Ensure brevity in your answer.  0.45. What is the ratio of the Secondary income (in US$) of Argentina in 2007 to that in 2012?
Ensure brevity in your answer.  0.46. What is the ratio of the Secondary income (in US$) in Myanmar in 2007 to that in 2012?
Your answer should be very brief. 0.24. What is the ratio of the Secondary income (in US$) of Singapore in 2007 to that in 2012?
Your response must be concise. 0.33. What is the ratio of the Secondary income (in US$) in Argentina in 2008 to that in 2009?
Your answer should be very brief. 0.92. What is the ratio of the Secondary income (in US$) of Myanmar in 2008 to that in 2009?
Make the answer very short. 0.83. What is the ratio of the Secondary income (in US$) of Singapore in 2008 to that in 2009?
Provide a succinct answer. 0.97. What is the ratio of the Secondary income (in US$) of Argentina in 2008 to that in 2010?
Offer a very short reply. 0.7. What is the ratio of the Secondary income (in US$) of Myanmar in 2008 to that in 2010?
Offer a terse response. 0.49. What is the ratio of the Secondary income (in US$) in Singapore in 2008 to that in 2010?
Keep it short and to the point. 0.71. What is the ratio of the Secondary income (in US$) in Argentina in 2008 to that in 2011?
Give a very brief answer. 0.59. What is the ratio of the Secondary income (in US$) in Myanmar in 2008 to that in 2011?
Provide a succinct answer. 0.51. What is the ratio of the Secondary income (in US$) of Singapore in 2008 to that in 2011?
Keep it short and to the point. 0.56. What is the ratio of the Secondary income (in US$) in Argentina in 2008 to that in 2012?
Provide a succinct answer. 0.64. What is the ratio of the Secondary income (in US$) in Myanmar in 2008 to that in 2012?
Provide a short and direct response. 0.46. What is the ratio of the Secondary income (in US$) in Singapore in 2008 to that in 2012?
Make the answer very short. 0.41. What is the ratio of the Secondary income (in US$) of Argentina in 2009 to that in 2010?
Ensure brevity in your answer.  0.76. What is the ratio of the Secondary income (in US$) in Myanmar in 2009 to that in 2010?
Ensure brevity in your answer.  0.59. What is the ratio of the Secondary income (in US$) of Singapore in 2009 to that in 2010?
Give a very brief answer. 0.73. What is the ratio of the Secondary income (in US$) of Argentina in 2009 to that in 2011?
Offer a very short reply. 0.64. What is the ratio of the Secondary income (in US$) of Myanmar in 2009 to that in 2011?
Your response must be concise. 0.61. What is the ratio of the Secondary income (in US$) in Singapore in 2009 to that in 2011?
Provide a short and direct response. 0.58. What is the ratio of the Secondary income (in US$) in Argentina in 2009 to that in 2012?
Ensure brevity in your answer.  0.69. What is the ratio of the Secondary income (in US$) in Myanmar in 2009 to that in 2012?
Offer a very short reply. 0.55. What is the ratio of the Secondary income (in US$) in Singapore in 2009 to that in 2012?
Offer a very short reply. 0.43. What is the ratio of the Secondary income (in US$) of Argentina in 2010 to that in 2011?
Your response must be concise. 0.84. What is the ratio of the Secondary income (in US$) in Myanmar in 2010 to that in 2011?
Offer a very short reply. 1.03. What is the ratio of the Secondary income (in US$) of Singapore in 2010 to that in 2011?
Offer a terse response. 0.79. What is the ratio of the Secondary income (in US$) in Argentina in 2010 to that in 2012?
Offer a very short reply. 0.91. What is the ratio of the Secondary income (in US$) of Myanmar in 2010 to that in 2012?
Provide a succinct answer. 0.94. What is the ratio of the Secondary income (in US$) of Singapore in 2010 to that in 2012?
Offer a terse response. 0.58. What is the ratio of the Secondary income (in US$) of Argentina in 2011 to that in 2012?
Make the answer very short. 1.08. What is the ratio of the Secondary income (in US$) of Myanmar in 2011 to that in 2012?
Your answer should be compact. 0.91. What is the ratio of the Secondary income (in US$) in Singapore in 2011 to that in 2012?
Ensure brevity in your answer.  0.73. What is the difference between the highest and the second highest Secondary income (in US$) of Argentina?
Your answer should be compact. 1.97e+08. What is the difference between the highest and the second highest Secondary income (in US$) of Myanmar?
Your response must be concise. 7.21e+06. What is the difference between the highest and the second highest Secondary income (in US$) of Singapore?
Provide a succinct answer. 3.79e+09. What is the difference between the highest and the lowest Secondary income (in US$) of Argentina?
Provide a short and direct response. 2.03e+09. What is the difference between the highest and the lowest Secondary income (in US$) of Myanmar?
Your response must be concise. 9.07e+07. What is the difference between the highest and the lowest Secondary income (in US$) in Singapore?
Your answer should be very brief. 1.09e+1. 